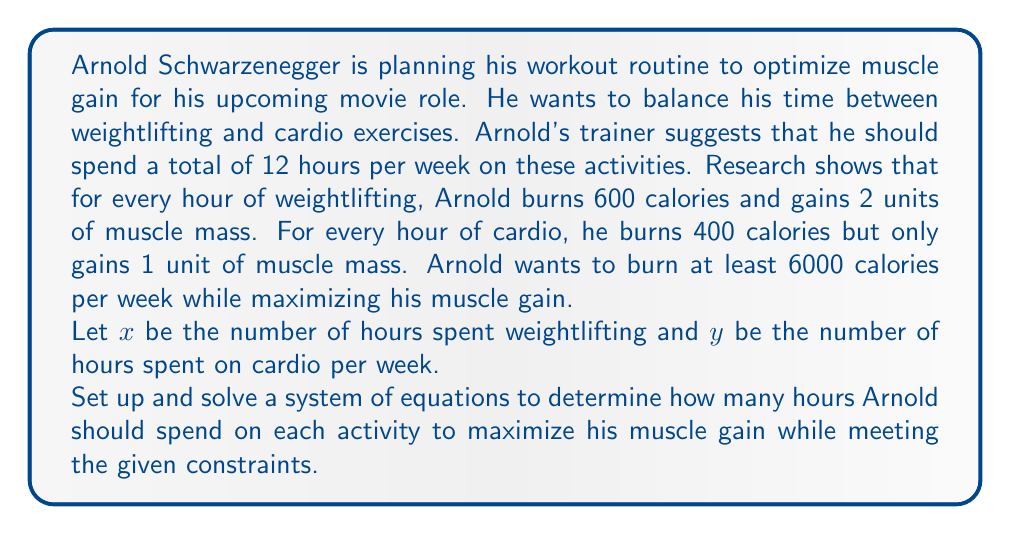Teach me how to tackle this problem. Let's approach this step-by-step:

1) First, let's set up our constraints:

   a) Total time constraint: $x + y = 12$
   b) Calorie burning constraint: $600x + 400y \geq 6000$

2) Our objective is to maximize muscle gain, which can be expressed as:
   $M = 2x + y$ (where M is the total muscle mass gained)

3) We can solve this system of equations graphically or algebraically. Let's use the algebraic method:

4) From the time constraint, we can express y in terms of x:
   $y = 12 - x$

5) Substituting this into the calorie constraint:
   $600x + 400(12 - x) \geq 6000$
   $600x + 4800 - 400x \geq 6000$
   $200x \geq 1200$
   $x \geq 6$

6) Since $x \geq 6$ and $x + y = 12$, the feasible region for x is $6 \leq x \leq 12$

7) Now, let's express our objective function in terms of x:
   $M = 2x + y = 2x + (12 - x) = x + 12$

8) This is a linear function that increases with x. Therefore, to maximize M, we should choose the largest possible value for x, which is 12.

9) When $x = 12$, $y = 0$

Therefore, to maximize muscle gain while meeting the constraints, Arnold should spend 12 hours on weightlifting and 0 hours on cardio.
Answer: Arnold should spend 12 hours on weightlifting and 0 hours on cardio per week to maximize muscle gain while meeting the given constraints. 